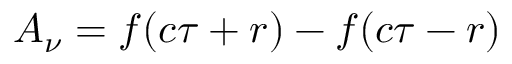Convert formula to latex. <formula><loc_0><loc_0><loc_500><loc_500>A _ { \nu } = f ( c \tau + r ) - f ( c \tau - r )</formula> 